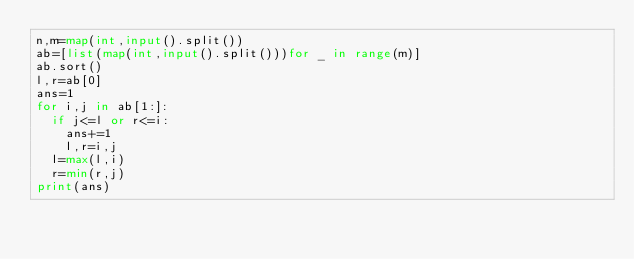<code> <loc_0><loc_0><loc_500><loc_500><_Python_>n,m=map(int,input().split())
ab=[list(map(int,input().split()))for _ in range(m)]
ab.sort()
l,r=ab[0]
ans=1
for i,j in ab[1:]:
  if j<=l or r<=i:
    ans+=1
    l,r=i,j
  l=max(l,i)
  r=min(r,j)
print(ans)</code> 